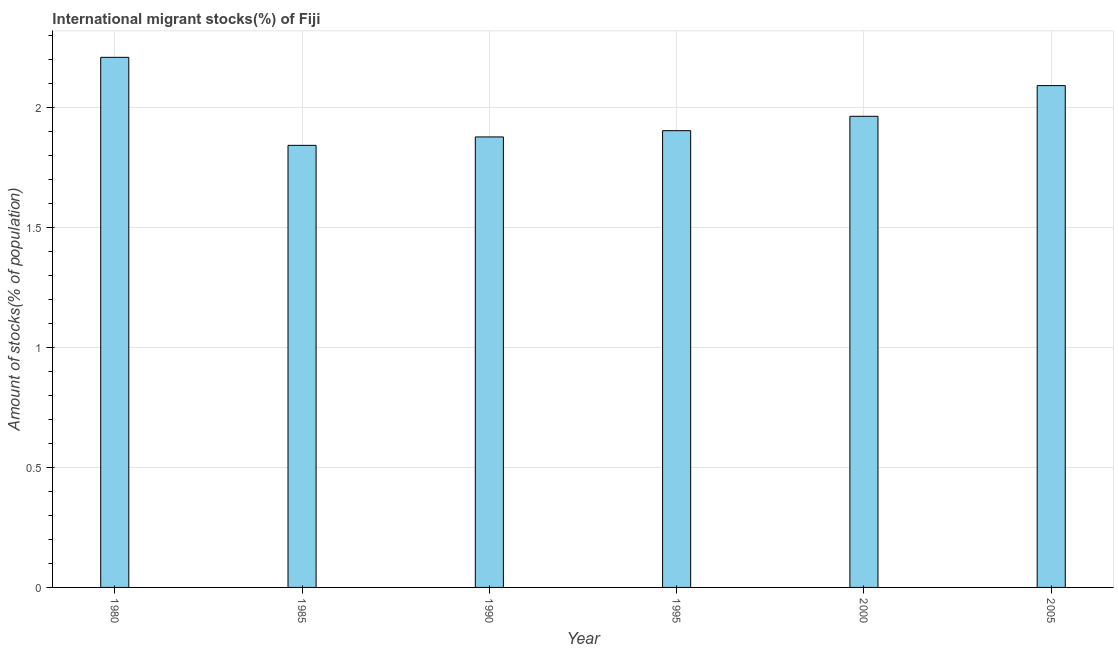Does the graph contain any zero values?
Your answer should be compact. No. What is the title of the graph?
Provide a short and direct response. International migrant stocks(%) of Fiji. What is the label or title of the Y-axis?
Ensure brevity in your answer.  Amount of stocks(% of population). What is the number of international migrant stocks in 2005?
Give a very brief answer. 2.09. Across all years, what is the maximum number of international migrant stocks?
Provide a succinct answer. 2.21. Across all years, what is the minimum number of international migrant stocks?
Keep it short and to the point. 1.84. In which year was the number of international migrant stocks minimum?
Your answer should be very brief. 1985. What is the sum of the number of international migrant stocks?
Give a very brief answer. 11.88. What is the difference between the number of international migrant stocks in 1985 and 2005?
Your answer should be very brief. -0.25. What is the average number of international migrant stocks per year?
Your answer should be compact. 1.98. What is the median number of international migrant stocks?
Ensure brevity in your answer.  1.93. In how many years, is the number of international migrant stocks greater than 0.5 %?
Make the answer very short. 6. What is the ratio of the number of international migrant stocks in 1980 to that in 1995?
Keep it short and to the point. 1.16. Is the number of international migrant stocks in 1985 less than that in 2005?
Offer a terse response. Yes. What is the difference between the highest and the second highest number of international migrant stocks?
Your answer should be very brief. 0.12. Is the sum of the number of international migrant stocks in 1990 and 2000 greater than the maximum number of international migrant stocks across all years?
Offer a very short reply. Yes. What is the difference between the highest and the lowest number of international migrant stocks?
Your response must be concise. 0.37. In how many years, is the number of international migrant stocks greater than the average number of international migrant stocks taken over all years?
Give a very brief answer. 2. Are all the bars in the graph horizontal?
Give a very brief answer. No. How many years are there in the graph?
Provide a succinct answer. 6. What is the difference between two consecutive major ticks on the Y-axis?
Your answer should be very brief. 0.5. Are the values on the major ticks of Y-axis written in scientific E-notation?
Offer a very short reply. No. What is the Amount of stocks(% of population) of 1980?
Provide a short and direct response. 2.21. What is the Amount of stocks(% of population) in 1985?
Your answer should be compact. 1.84. What is the Amount of stocks(% of population) of 1990?
Ensure brevity in your answer.  1.88. What is the Amount of stocks(% of population) of 1995?
Your answer should be very brief. 1.9. What is the Amount of stocks(% of population) of 2000?
Your answer should be compact. 1.96. What is the Amount of stocks(% of population) in 2005?
Ensure brevity in your answer.  2.09. What is the difference between the Amount of stocks(% of population) in 1980 and 1985?
Offer a very short reply. 0.37. What is the difference between the Amount of stocks(% of population) in 1980 and 1990?
Your answer should be very brief. 0.33. What is the difference between the Amount of stocks(% of population) in 1980 and 1995?
Your response must be concise. 0.31. What is the difference between the Amount of stocks(% of population) in 1980 and 2000?
Provide a succinct answer. 0.25. What is the difference between the Amount of stocks(% of population) in 1980 and 2005?
Your response must be concise. 0.12. What is the difference between the Amount of stocks(% of population) in 1985 and 1990?
Provide a succinct answer. -0.04. What is the difference between the Amount of stocks(% of population) in 1985 and 1995?
Offer a terse response. -0.06. What is the difference between the Amount of stocks(% of population) in 1985 and 2000?
Your answer should be compact. -0.12. What is the difference between the Amount of stocks(% of population) in 1985 and 2005?
Your response must be concise. -0.25. What is the difference between the Amount of stocks(% of population) in 1990 and 1995?
Keep it short and to the point. -0.03. What is the difference between the Amount of stocks(% of population) in 1990 and 2000?
Provide a succinct answer. -0.09. What is the difference between the Amount of stocks(% of population) in 1990 and 2005?
Provide a succinct answer. -0.21. What is the difference between the Amount of stocks(% of population) in 1995 and 2000?
Offer a very short reply. -0.06. What is the difference between the Amount of stocks(% of population) in 1995 and 2005?
Your response must be concise. -0.19. What is the difference between the Amount of stocks(% of population) in 2000 and 2005?
Keep it short and to the point. -0.13. What is the ratio of the Amount of stocks(% of population) in 1980 to that in 1985?
Your response must be concise. 1.2. What is the ratio of the Amount of stocks(% of population) in 1980 to that in 1990?
Ensure brevity in your answer.  1.18. What is the ratio of the Amount of stocks(% of population) in 1980 to that in 1995?
Your answer should be compact. 1.16. What is the ratio of the Amount of stocks(% of population) in 1980 to that in 2005?
Your answer should be compact. 1.06. What is the ratio of the Amount of stocks(% of population) in 1985 to that in 1990?
Offer a terse response. 0.98. What is the ratio of the Amount of stocks(% of population) in 1985 to that in 1995?
Offer a very short reply. 0.97. What is the ratio of the Amount of stocks(% of population) in 1985 to that in 2000?
Your answer should be compact. 0.94. What is the ratio of the Amount of stocks(% of population) in 1985 to that in 2005?
Your answer should be very brief. 0.88. What is the ratio of the Amount of stocks(% of population) in 1990 to that in 2000?
Ensure brevity in your answer.  0.96. What is the ratio of the Amount of stocks(% of population) in 1990 to that in 2005?
Offer a very short reply. 0.9. What is the ratio of the Amount of stocks(% of population) in 1995 to that in 2000?
Give a very brief answer. 0.97. What is the ratio of the Amount of stocks(% of population) in 1995 to that in 2005?
Offer a very short reply. 0.91. What is the ratio of the Amount of stocks(% of population) in 2000 to that in 2005?
Your response must be concise. 0.94. 